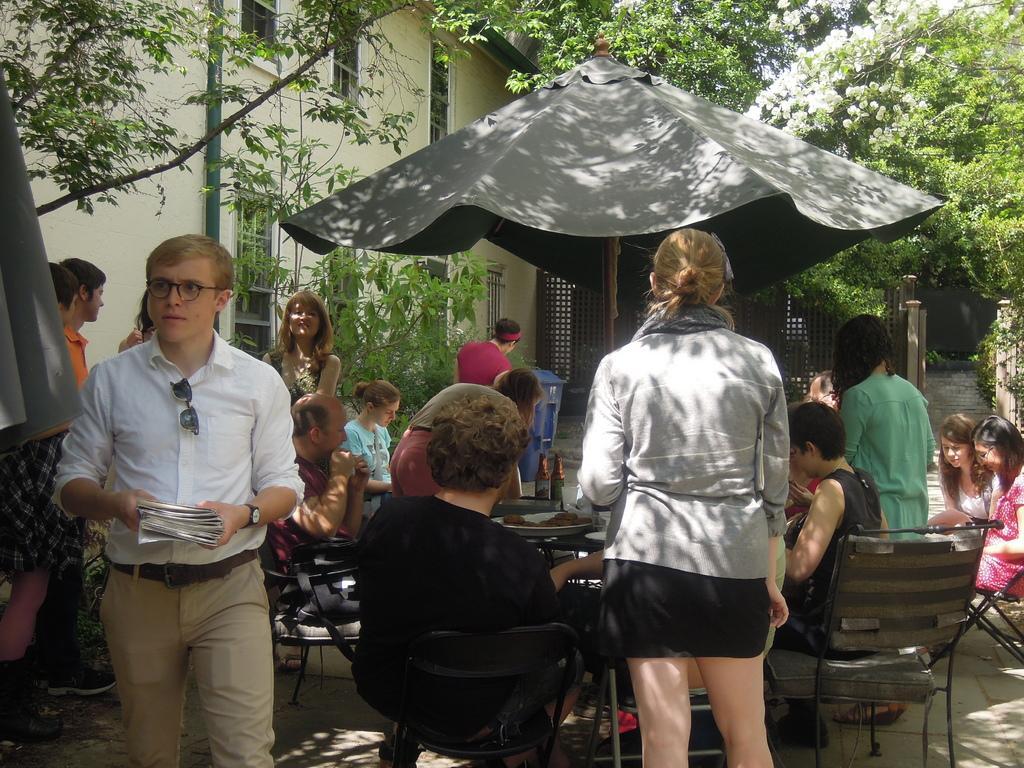Please provide a concise description of this image. In this image we can see a group of people. Behind the persons there are some chairs and objects on the table. On the left side of the image there is a building. Behind the persons there are groups of trees. 